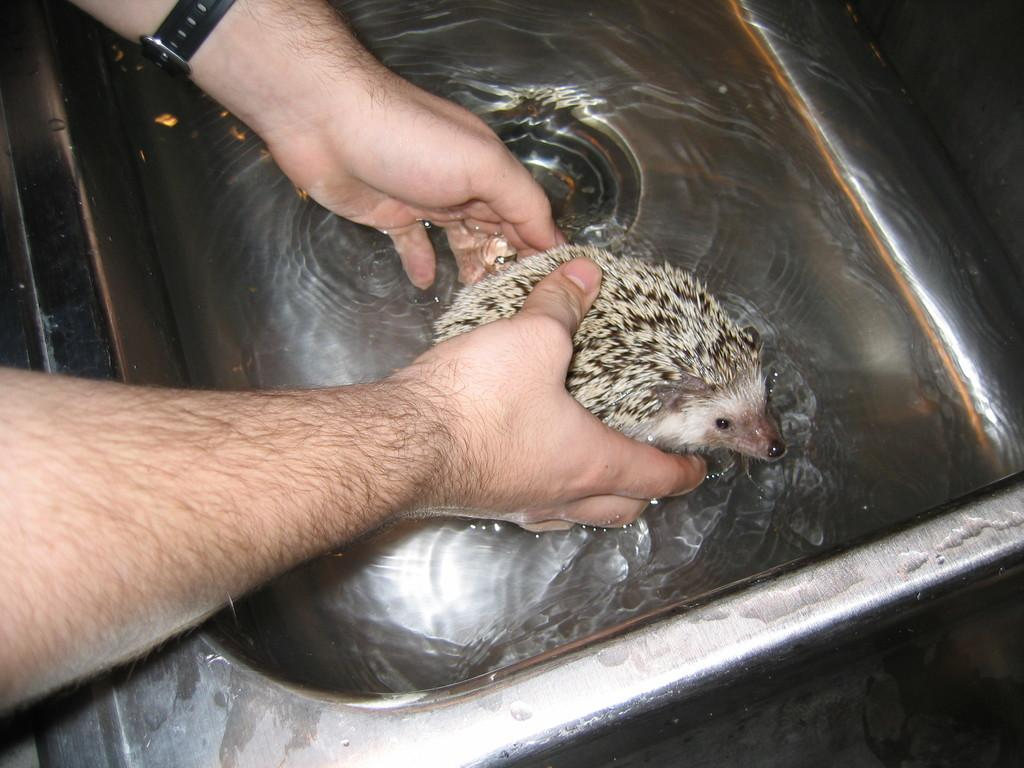What is the person holding in the image? The person is holding an animal in the image. What object is present in the image that is typically used for washing hands? There is a wash basin in the image. Can you describe the presence of water in the image? There is water visible in the image. How does the person's aunt react to the sleet in the image? There is no mention of an aunt or sleet in the image, so it's not possible to determine how the aunt would react to sleet. 